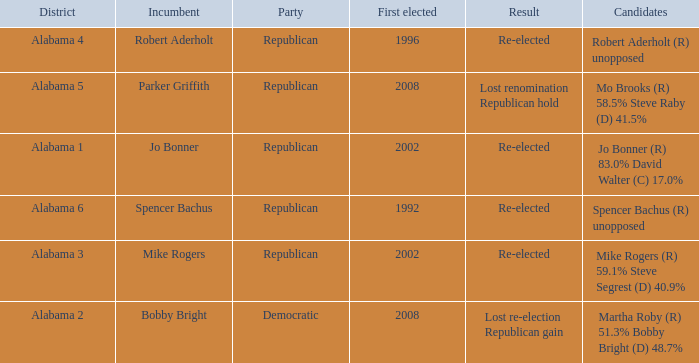Name the result for first elected being 1992 Re-elected. 